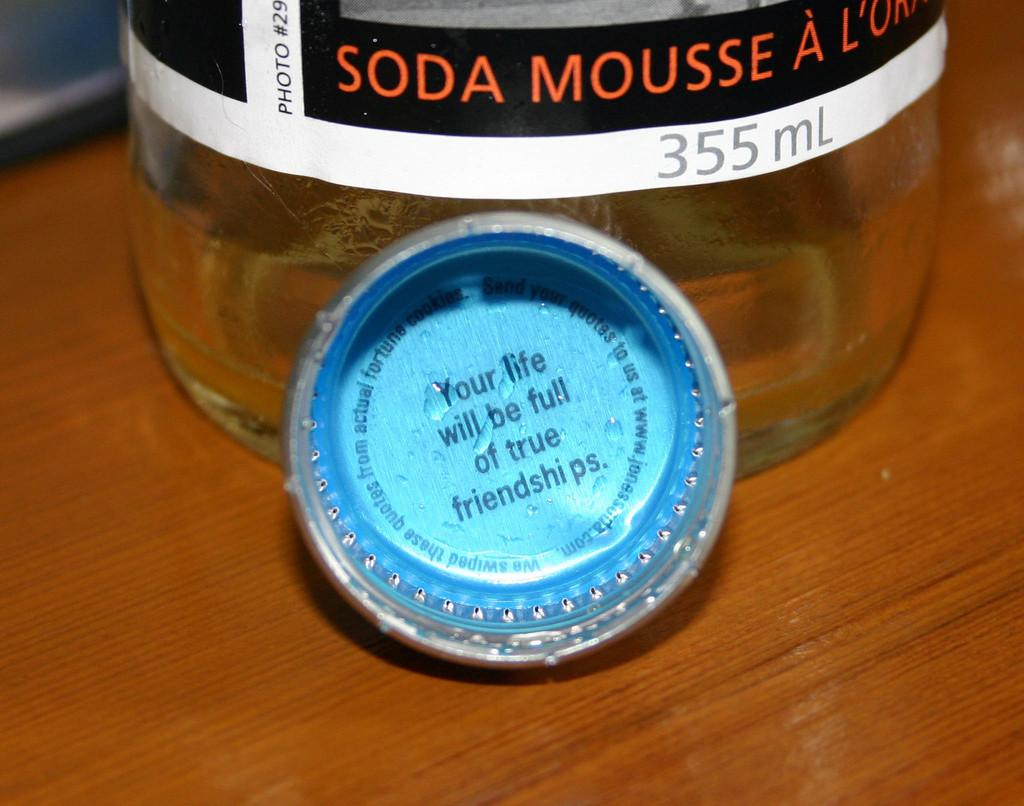<image>
Share a concise interpretation of the image provided. a close up of soda mousse a with a bottle cap with words about "your life" 